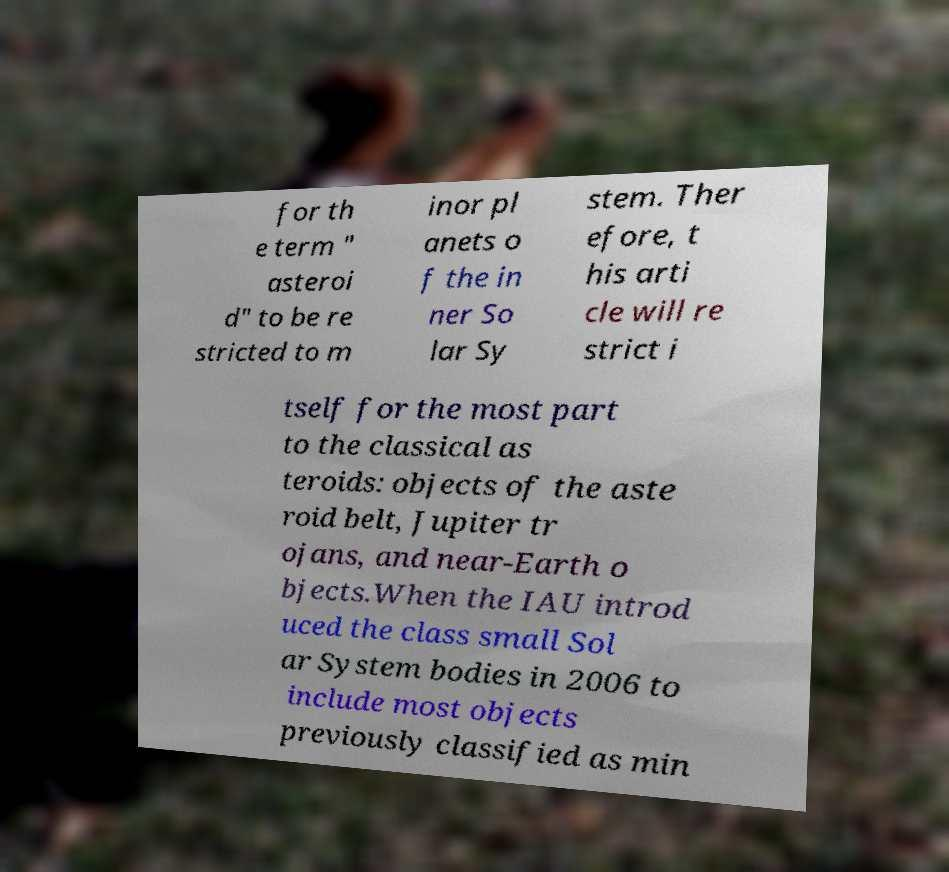I need the written content from this picture converted into text. Can you do that? for th e term " asteroi d" to be re stricted to m inor pl anets o f the in ner So lar Sy stem. Ther efore, t his arti cle will re strict i tself for the most part to the classical as teroids: objects of the aste roid belt, Jupiter tr ojans, and near-Earth o bjects.When the IAU introd uced the class small Sol ar System bodies in 2006 to include most objects previously classified as min 